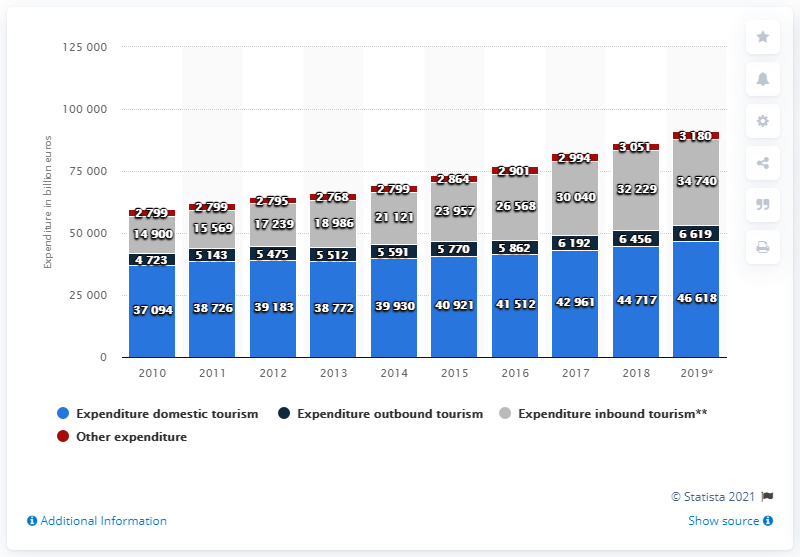Mention a couple of crucial points in this snapshot. The total expenditure for domestic tourism in the Netherlands in 2019 was 46,618. According to data from 2019, the total amount of inbound tourism spending in the Netherlands was approximately 34,740 million euros. 